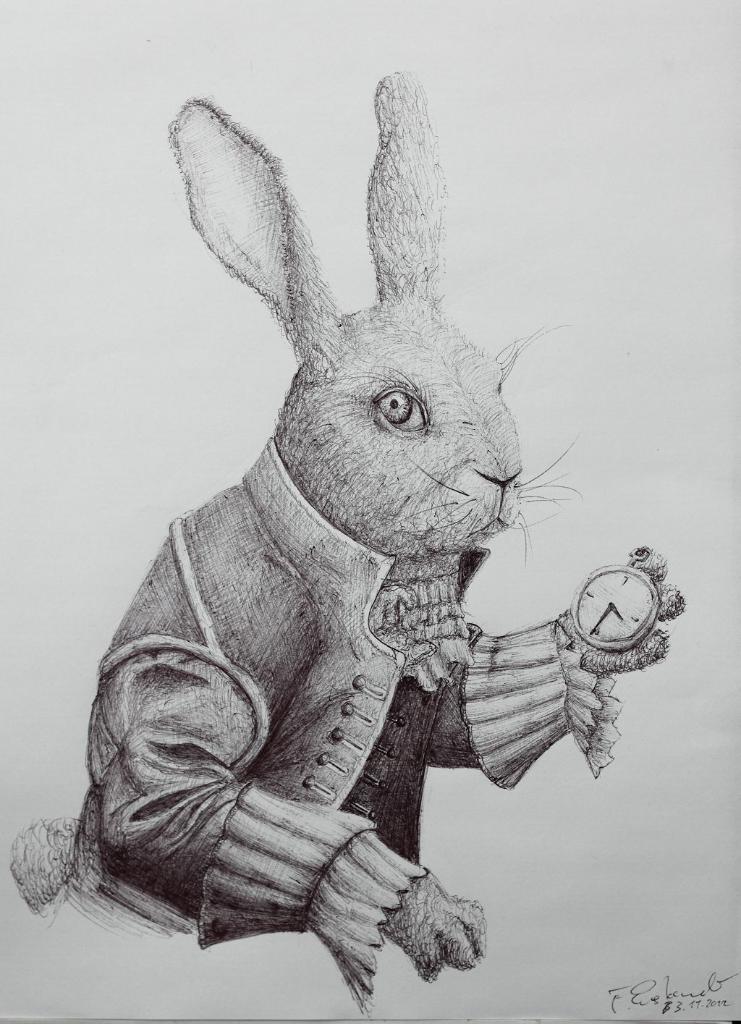How would you summarize this image in a sentence or two? This image consists of a paper with an art. This art is done with a pencil on the paper. In this art there is a rabbit holding stopwatch in hand. 